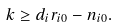<formula> <loc_0><loc_0><loc_500><loc_500>k \geq d _ { i } r _ { i 0 } - n _ { i 0 } .</formula> 